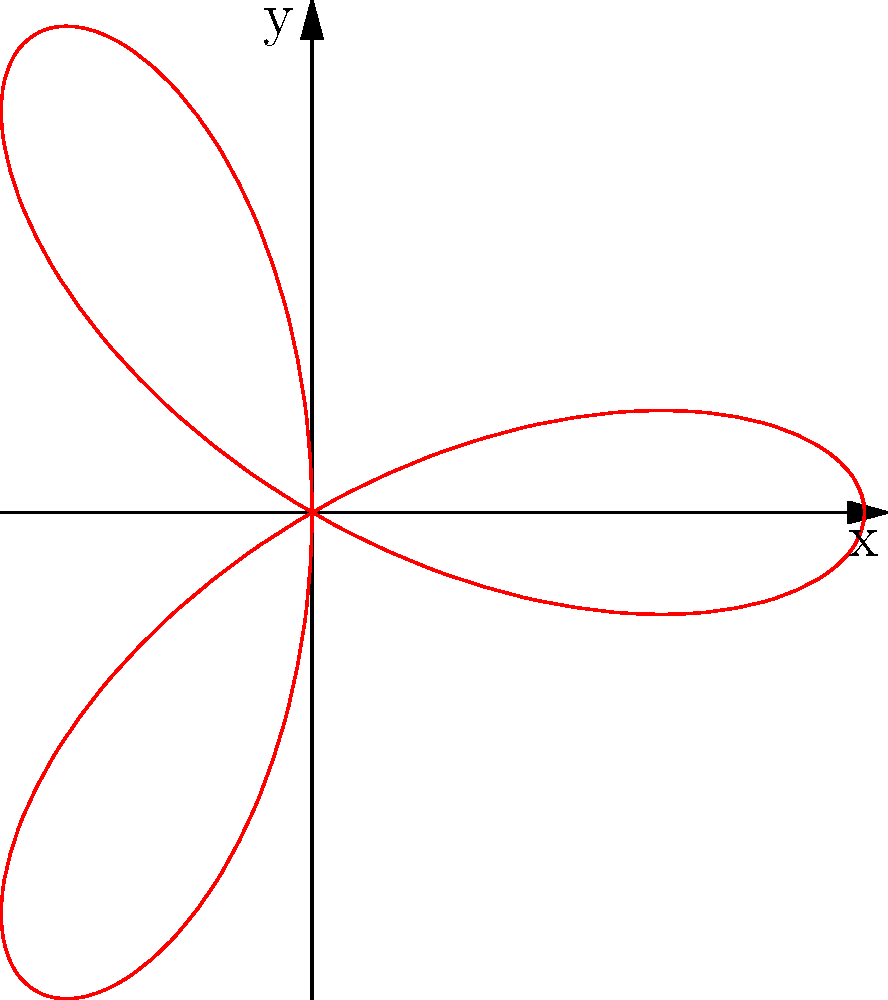Given the polar equation $r = \cos(3\theta)$, which represents a rose with 3 petals, calculate the total area enclosed by the curve. Round your answer to two decimal places. Let's approach this step-by-step:

1) The area of a polar rose is given by the formula:

   $$A = \frac{n}{2} \int_0^{\frac{2\pi}{n}} r^2(\theta) d\theta$$

   where $n$ is the number of petals.

2) In this case, $n = 3$ and $r(\theta) = \cos(3\theta)$. Let's substitute these into the formula:

   $$A = \frac{3}{2} \int_0^{\frac{2\pi}{3}} \cos^2(3\theta) d\theta$$

3) To solve this integral, we can use the trigonometric identity:

   $$\cos^2(x) = \frac{1 + \cos(2x)}{2}$$

4) Applying this to our integral:

   $$A = \frac{3}{2} \int_0^{\frac{2\pi}{3}} \frac{1 + \cos(6\theta)}{2} d\theta$$

5) Simplifying:

   $$A = \frac{3}{4} \int_0^{\frac{2\pi}{3}} (1 + \cos(6\theta)) d\theta$$

6) Integrating:

   $$A = \frac{3}{4} [\theta + \frac{1}{6}\sin(6\theta)]_0^{\frac{2\pi}{3}}$$

7) Evaluating the bounds:

   $$A = \frac{3}{4} [(\frac{2\pi}{3} + 0) - (0 + 0)] = \frac{3}{4} \cdot \frac{2\pi}{3} = \frac{\pi}{2}$$

8) $\frac{\pi}{2} \approx 1.57$

Therefore, the area enclosed by the curve, rounded to two decimal places, is 1.57 square units.
Answer: 1.57 square units 